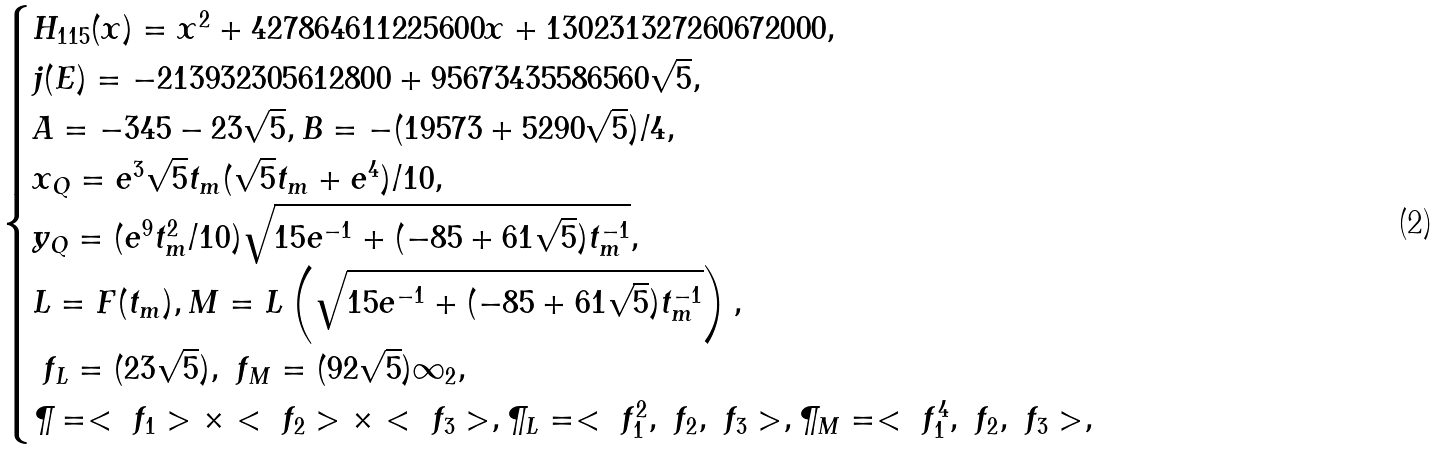Convert formula to latex. <formula><loc_0><loc_0><loc_500><loc_500>\begin{cases} H _ { 1 1 5 } ( x ) = x ^ { 2 } + 4 2 7 8 6 4 6 1 1 2 2 5 6 0 0 x + 1 3 0 2 3 1 3 2 7 2 6 0 6 7 2 0 0 0 , \\ j ( E ) = - 2 1 3 9 3 2 3 0 5 6 1 2 8 0 0 + 9 5 6 7 3 4 3 5 5 8 6 5 6 0 \sqrt { 5 } , \\ A = - 3 4 5 - 2 3 \sqrt { 5 } , B = - ( 1 9 5 7 3 + 5 2 9 0 \sqrt { 5 } ) / 4 , \\ x _ { Q } = e ^ { 3 } \sqrt { 5 } t _ { m } ( \sqrt { 5 } t _ { m } + e ^ { 4 } ) / 1 0 , \\ y _ { Q } = ( e ^ { 9 } t _ { m } ^ { 2 } / 1 0 ) \sqrt { 1 5 e ^ { - 1 } + ( - 8 5 + 6 1 \sqrt { 5 } ) t ^ { - 1 } _ { m } } , \\ L = F ( t _ { m } ) , M = L \left ( \sqrt { 1 5 e ^ { - 1 } + ( - 8 5 + 6 1 \sqrt { 5 } ) t ^ { - 1 } _ { m } } \right ) , \\ \ f _ { L } = ( 2 3 \sqrt { 5 } ) , \ f _ { M } = ( 9 2 \sqrt { 5 } ) \infty _ { 2 } , \\ \P = < \ f _ { 1 } > \times < \ f _ { 2 } > \times < \ f _ { 3 } > , \P _ { L } = < \ f _ { 1 } ^ { 2 } , \ f _ { 2 } , \ f _ { 3 } > , \P _ { M } = < \ f _ { 1 } ^ { 4 } , \ f _ { 2 } , \ f _ { 3 } > , \end{cases}</formula> 